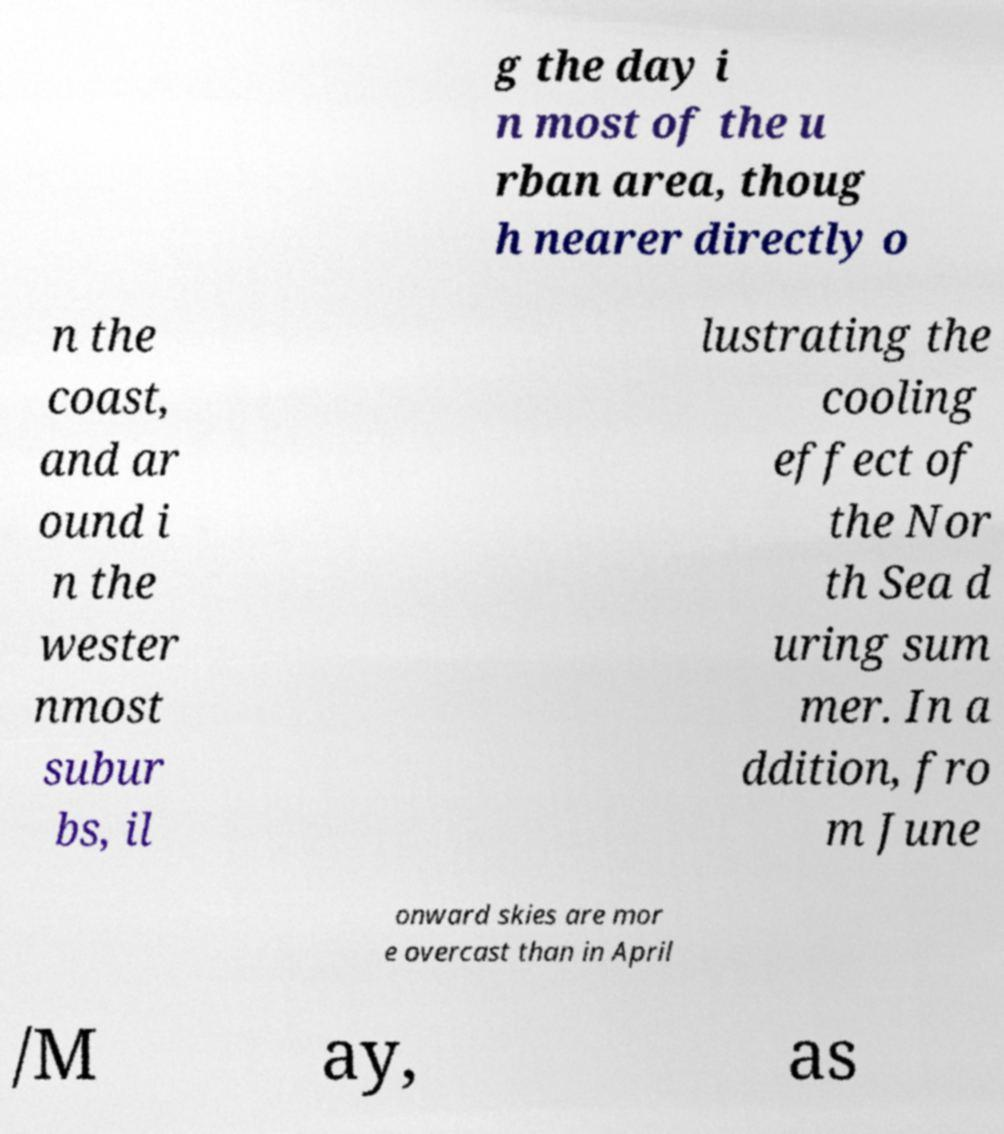Could you assist in decoding the text presented in this image and type it out clearly? g the day i n most of the u rban area, thoug h nearer directly o n the coast, and ar ound i n the wester nmost subur bs, il lustrating the cooling effect of the Nor th Sea d uring sum mer. In a ddition, fro m June onward skies are mor e overcast than in April /M ay, as 